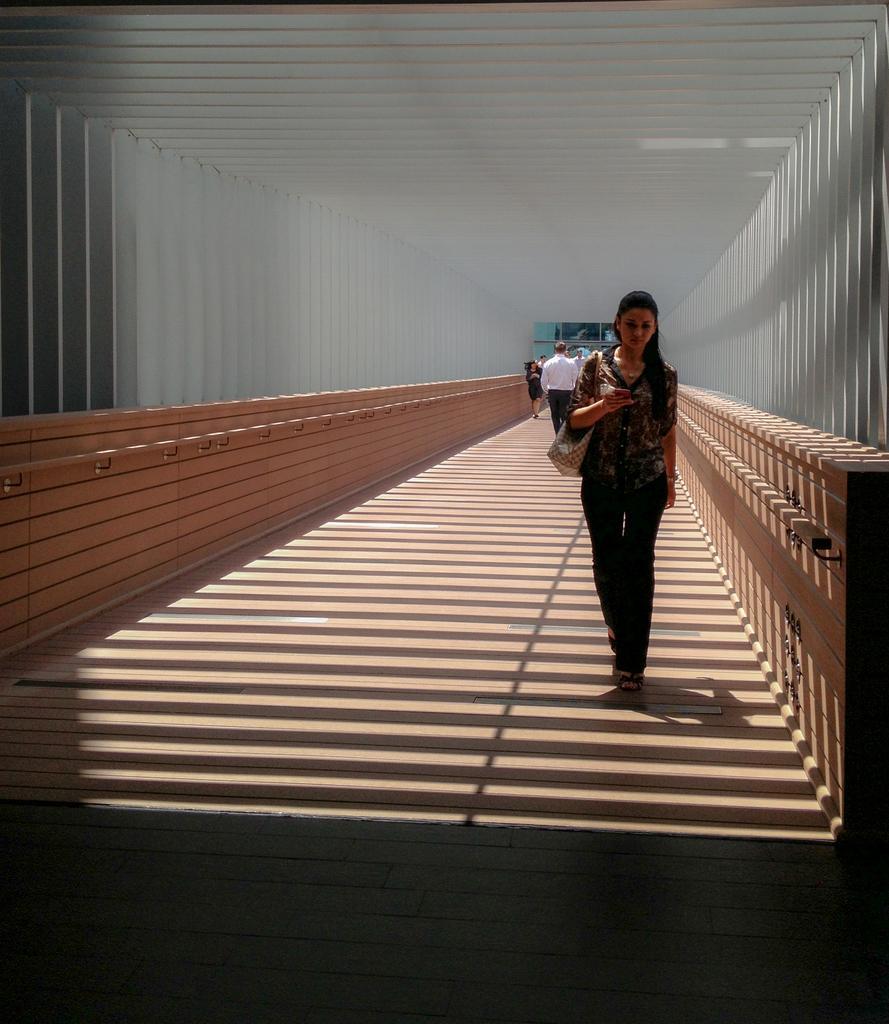Describe this image in one or two sentences. In the picture we can see a woman walking on the floor and she is wearing a hand bag and besides her we can see a wall with a railing which is white in color and behind her far away we can see some people are also walking. 